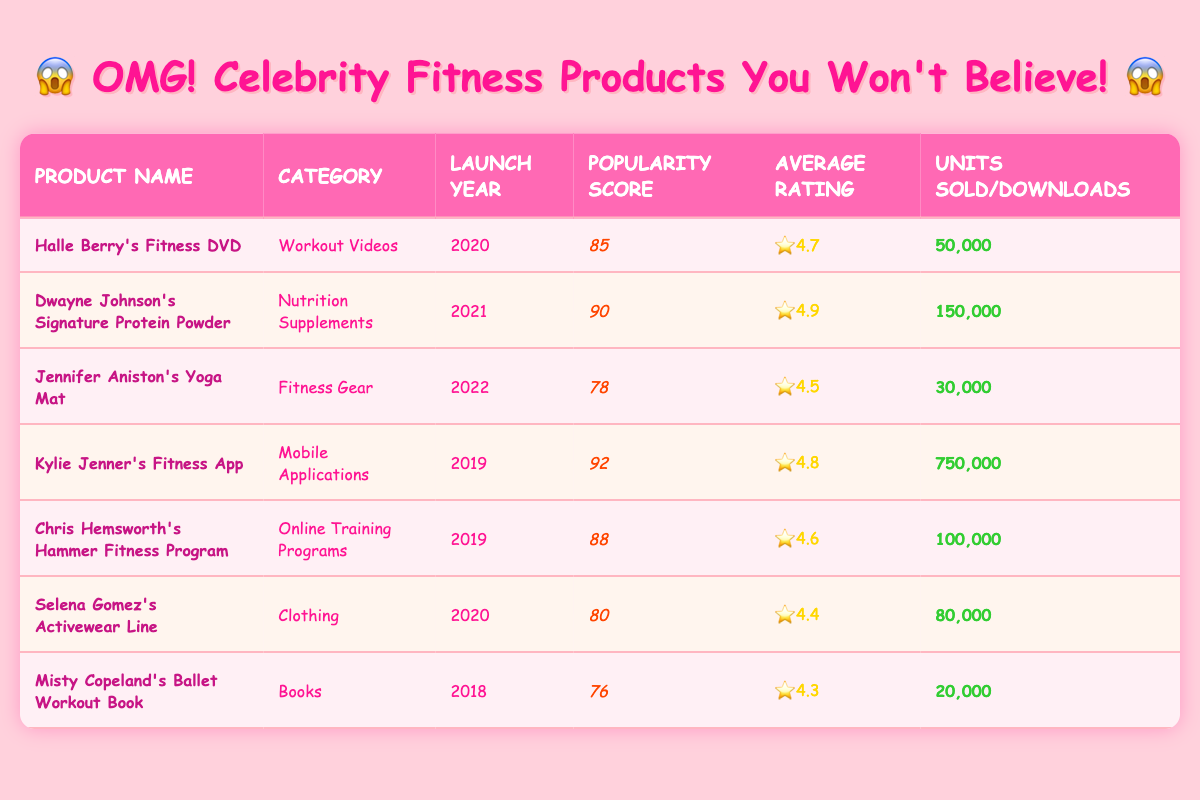What is the highest popularity score among the products listed? Dwayne Johnson's Signature Protein Powder has the highest popularity score of 90. This can be found by comparing the popularity scores from each row in the table and identifying the maximum value.
Answer: 90 What product has the lowest average rating? Misty Copeland's Ballet Workout Book has the lowest average rating of 4.3. This is determined by checking the average ratings for each product and selecting the minimum value.
Answer: 4.3 How many units were sold for both Selena Gomez's Activewear Line and Halle Berry's Fitness DVD combined? Selena Gomez's Activewear Line sold 80,000 units and Halle Berry's Fitness DVD sold 50,000 units. Adding these two figures gives a total of 80,000 + 50,000 = 130,000 units sold.
Answer: 130,000 Is Kylie Jenner's Fitness App categorized as a nutrition supplement? No, Kylie Jenner's Fitness App is categorized as a Mobile Application, not a Nutrition Supplement. This can be confirmed by checking the category column for the respective product.
Answer: No What is the difference in units sold between Dwayne Johnson's Signature Protein Powder and Misty Copeland's Ballet Workout Book? Dwayne Johnson's Signature Protein Powder sold 150,000 units, while Misty Copeland's Ballet Workout Book sold 20,000 units. The difference is 150,000 - 20,000 = 130,000 units.
Answer: 130,000 